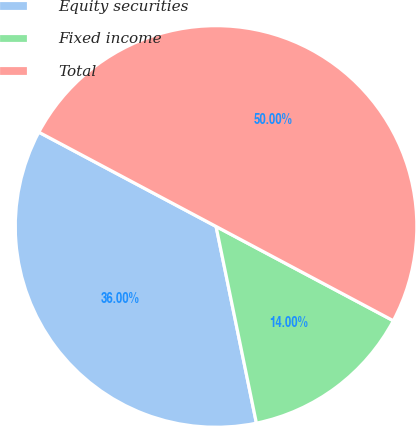Convert chart to OTSL. <chart><loc_0><loc_0><loc_500><loc_500><pie_chart><fcel>Equity securities<fcel>Fixed income<fcel>Total<nl><fcel>36.0%<fcel>14.0%<fcel>50.0%<nl></chart> 